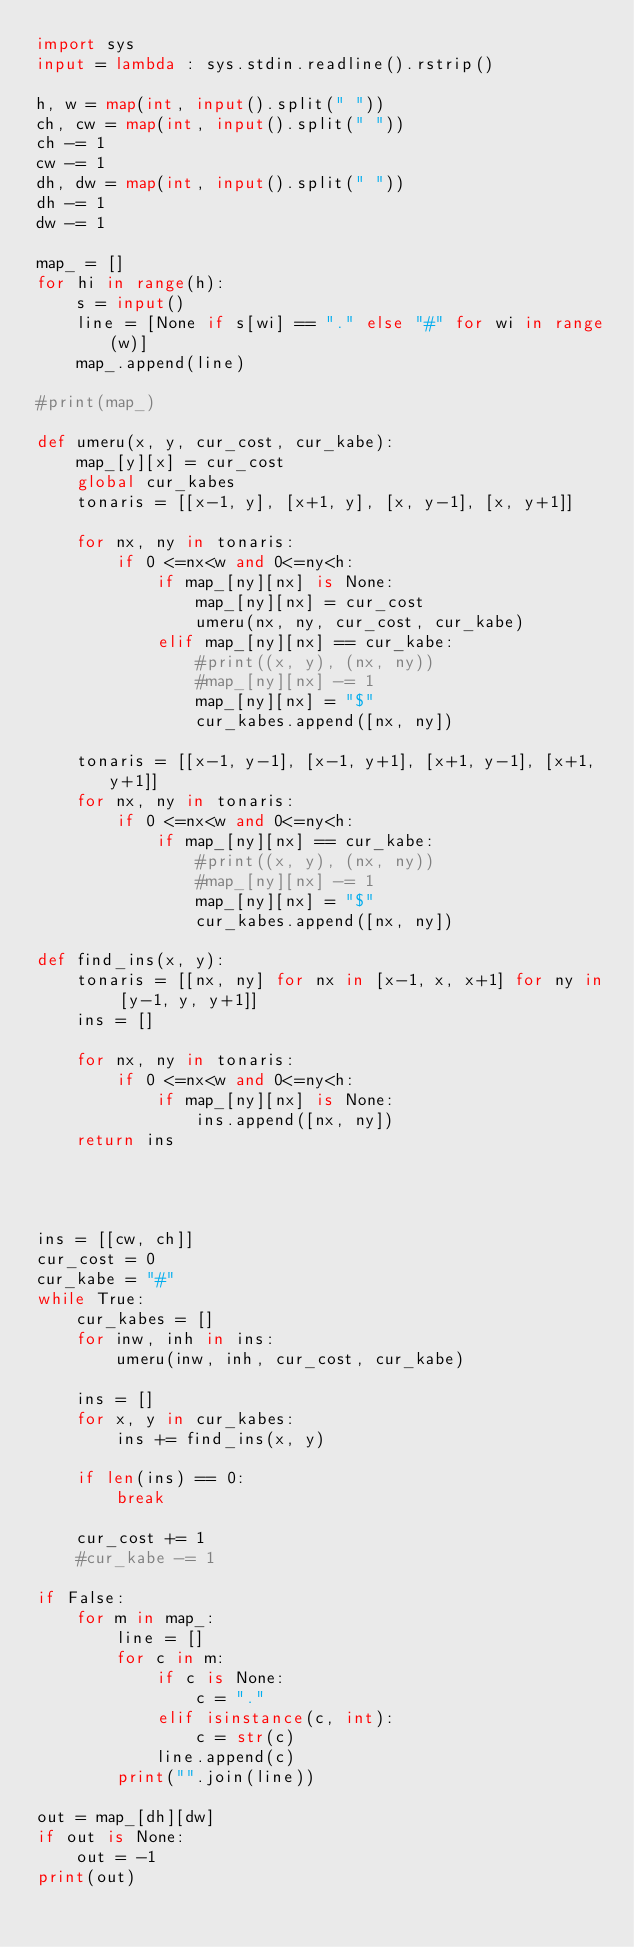Convert code to text. <code><loc_0><loc_0><loc_500><loc_500><_Python_>import sys
input = lambda : sys.stdin.readline().rstrip()

h, w = map(int, input().split(" "))
ch, cw = map(int, input().split(" "))
ch -= 1
cw -= 1
dh, dw = map(int, input().split(" "))
dh -= 1
dw -= 1

map_ = []
for hi in range(h):
    s = input()
    line = [None if s[wi] == "." else "#" for wi in range(w)]
    map_.append(line)        

#print(map_)

def umeru(x, y, cur_cost, cur_kabe):
    map_[y][x] = cur_cost
    global cur_kabes
    tonaris = [[x-1, y], [x+1, y], [x, y-1], [x, y+1]]

    for nx, ny in tonaris:
        if 0 <=nx<w and 0<=ny<h:
            if map_[ny][nx] is None:
                map_[ny][nx] = cur_cost
                umeru(nx, ny, cur_cost, cur_kabe)
            elif map_[ny][nx] == cur_kabe:
                #print((x, y), (nx, ny))
                #map_[ny][nx] -= 1
                map_[ny][nx] = "$"
                cur_kabes.append([nx, ny])

    tonaris = [[x-1, y-1], [x-1, y+1], [x+1, y-1], [x+1, y+1]]
    for nx, ny in tonaris:
        if 0 <=nx<w and 0<=ny<h:
            if map_[ny][nx] == cur_kabe:
                #print((x, y), (nx, ny))
                #map_[ny][nx] -= 1
                map_[ny][nx] = "$"
                cur_kabes.append([nx, ny])

def find_ins(x, y):
    tonaris = [[nx, ny] for nx in [x-1, x, x+1] for ny in [y-1, y, y+1]]
    ins = []
    
    for nx, ny in tonaris:
        if 0 <=nx<w and 0<=ny<h:
            if map_[ny][nx] is None:
                ins.append([nx, ny])
    return ins


                
                
ins = [[cw, ch]]
cur_cost = 0
cur_kabe = "#"
while True:
    cur_kabes = []
    for inw, inh in ins:
        umeru(inw, inh, cur_cost, cur_kabe)

    ins = []
    for x, y in cur_kabes:
        ins += find_ins(x, y)

    if len(ins) == 0:
        break
        
    cur_cost += 1
    #cur_kabe -= 1

if False:
    for m in map_:
        line = []
        for c in m:
            if c is None:
                c = "."
            elif isinstance(c, int):
                c = str(c)
            line.append(c)
        print("".join(line))

out = map_[dh][dw]
if out is None:
    out = -1
print(out)</code> 